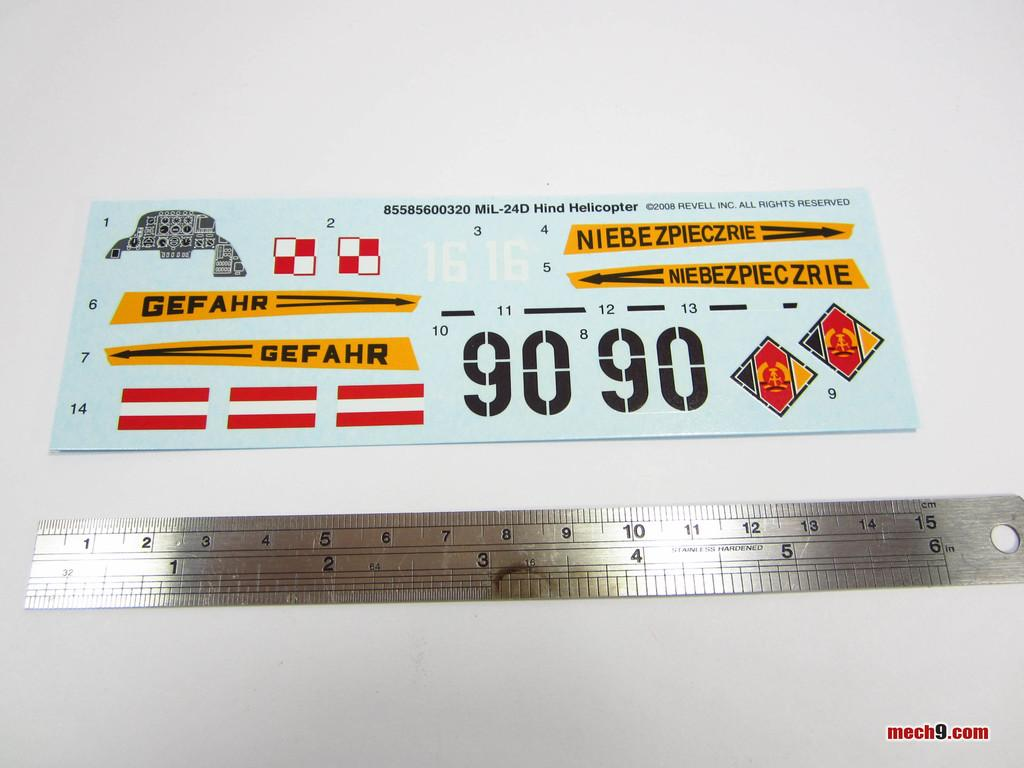<image>
Provide a brief description of the given image. The stainless hardened ruler goes up to 6 inches. 